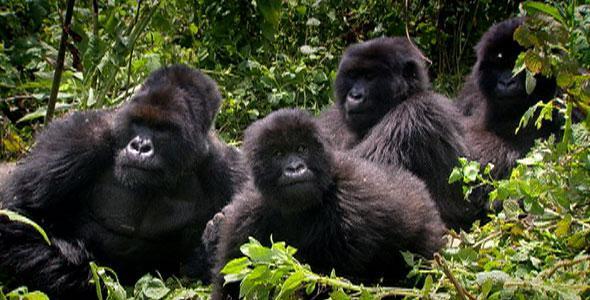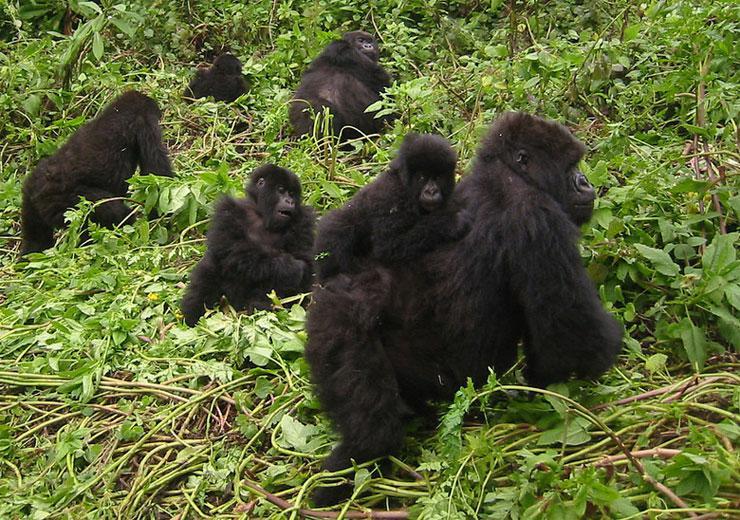The first image is the image on the left, the second image is the image on the right. Analyze the images presented: Is the assertion "There are no more than two gorillas in the right image." valid? Answer yes or no. No. The first image is the image on the left, the second image is the image on the right. Analyze the images presented: Is the assertion "At least one image contains no more than two gorillas and contains at least one adult male." valid? Answer yes or no. No. 